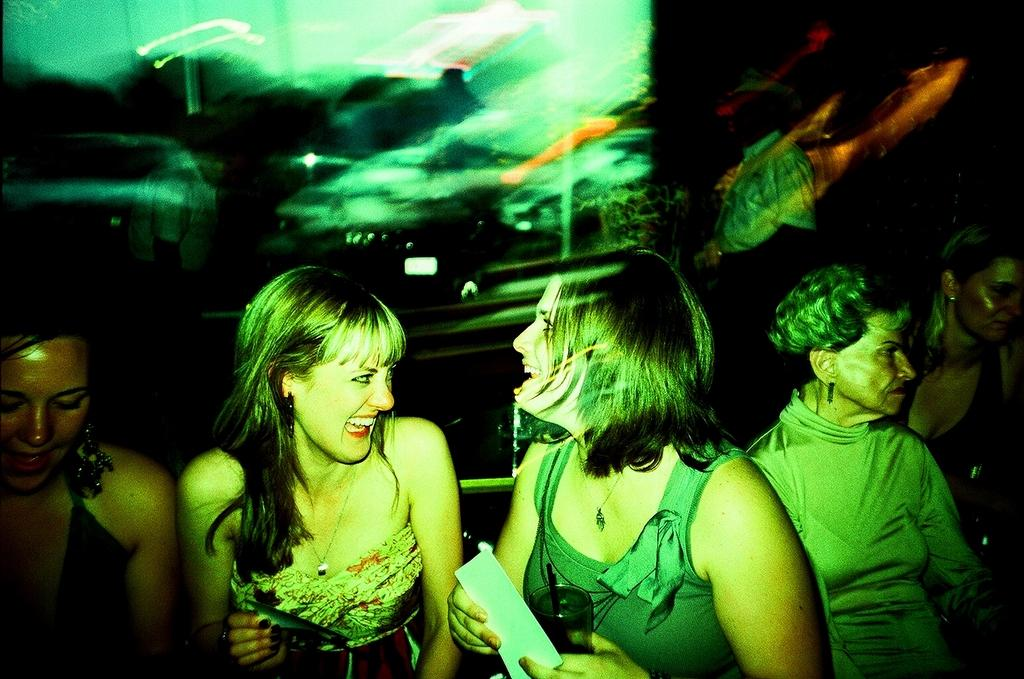How many people are in the image? There is a group of people in the image. What is the woman holding in the image? The woman is holding a card and a glass. What is the other person holding in the image? Another person is holding an object. What can be seen in the background or surroundings of the image? There are lights visible in the image. What type of corn is being grown in the image? There is no corn present in the image. What kind of beast can be seen in the image? There is no beast present in the image. 